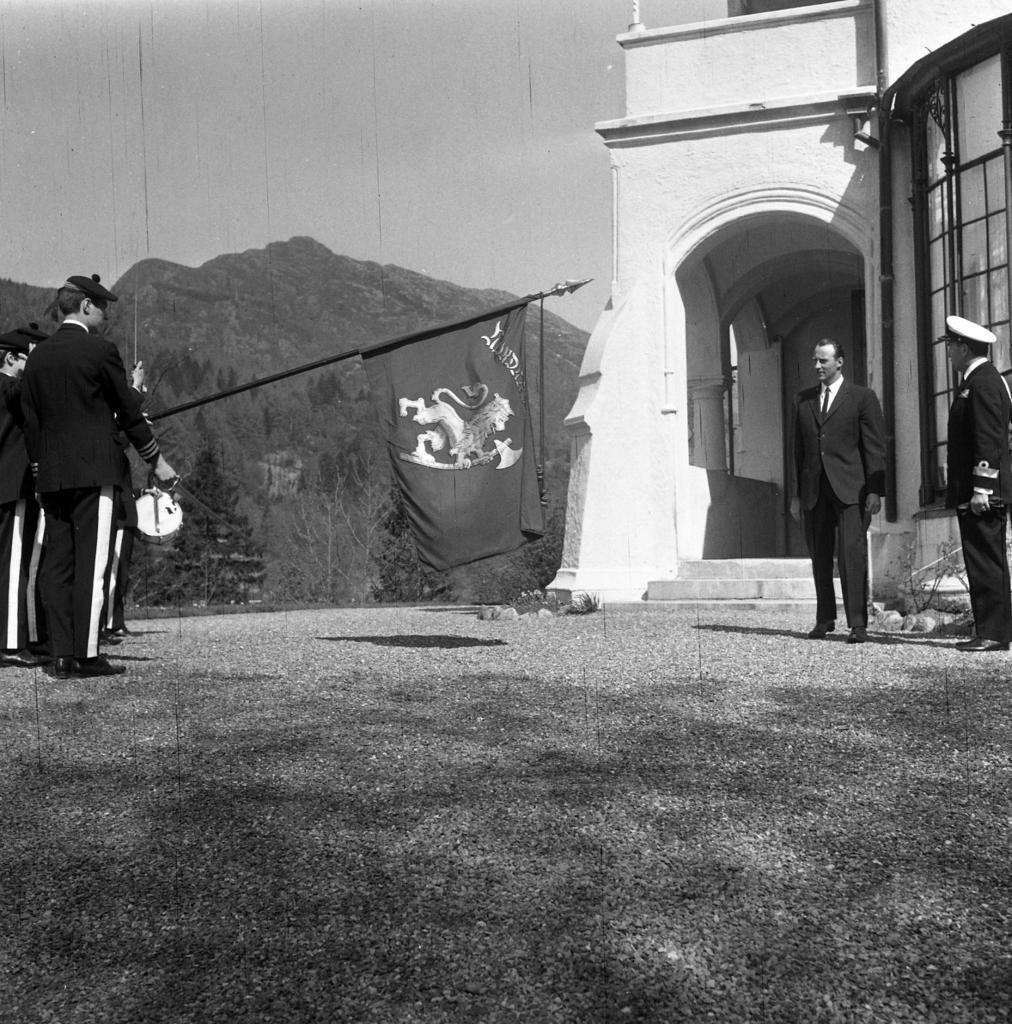How would you summarize this image in a sentence or two? In this image I can see few people standing and I can also see the person holding the flag. In the background I can see the building and mountains and the image is in black and white. 